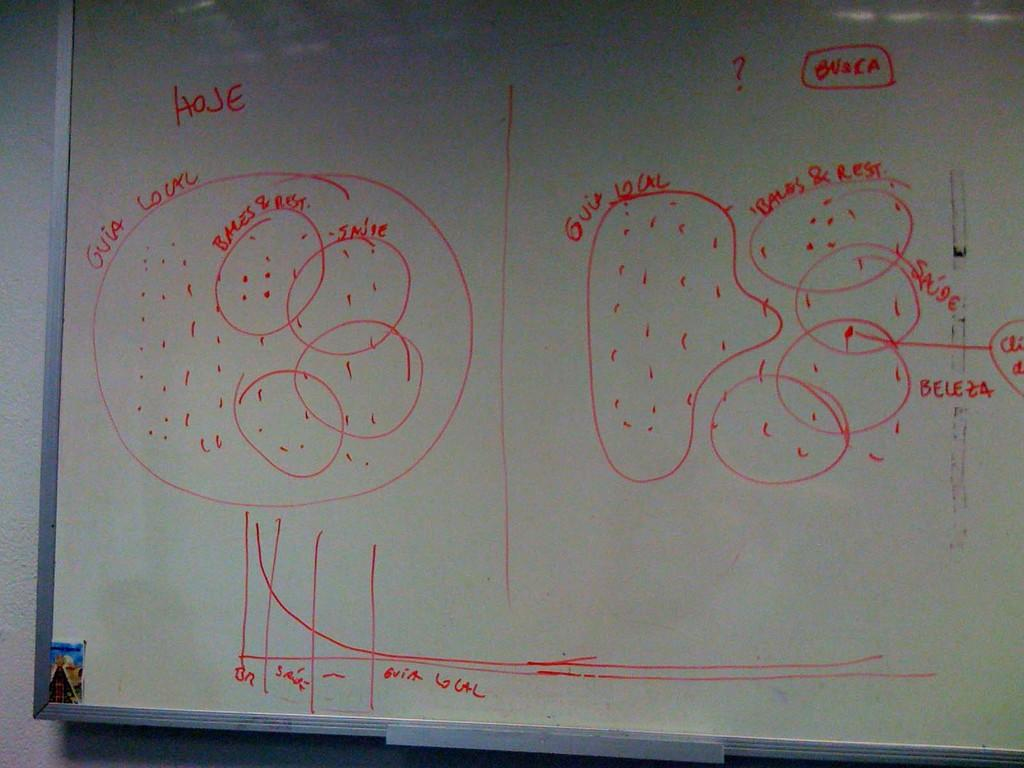<image>
Create a compact narrative representing the image presented. A white board has "Hoje" and "Busca" written on it in red. 